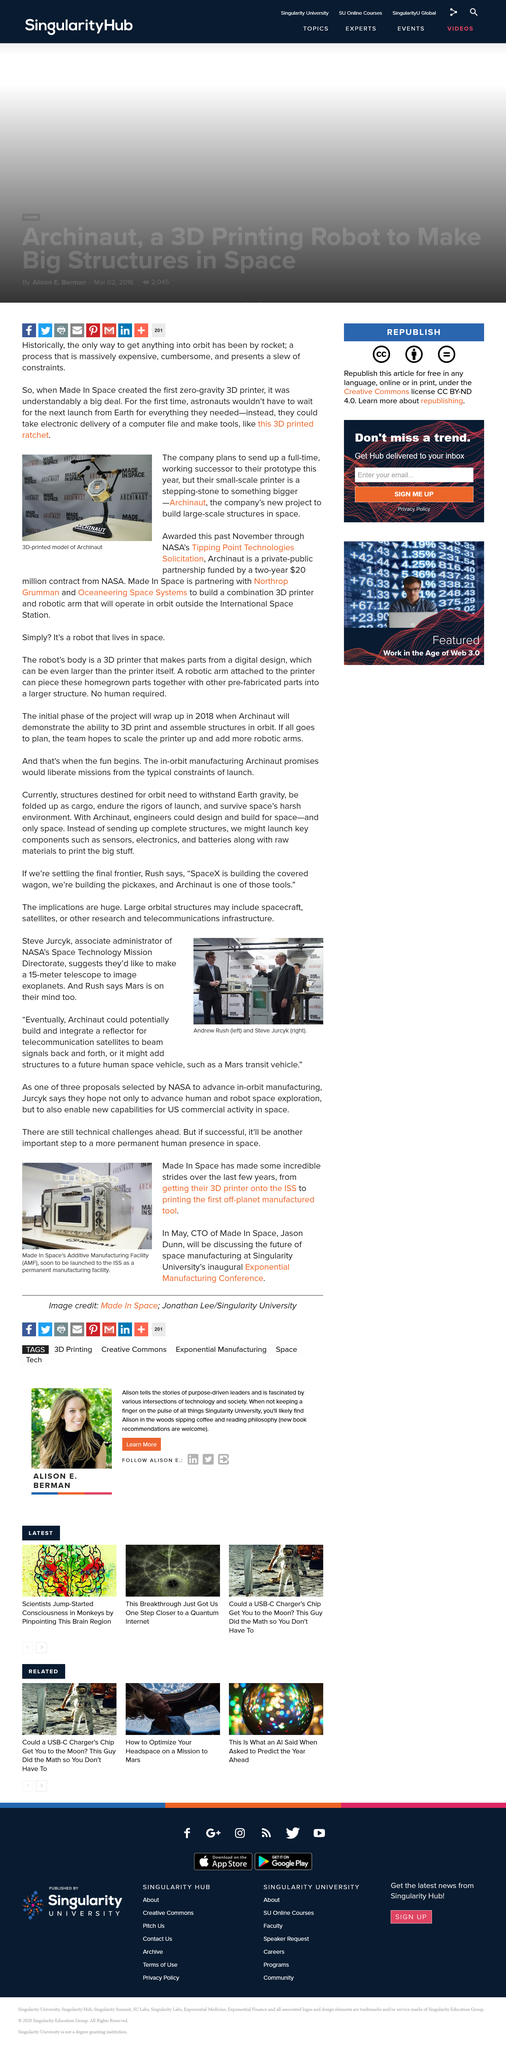Mention a couple of crucial points in this snapshot. Steve Jurcyk is the Associate Administrator of NASA's Space Technology Mission Directorate. Jason Dunn is the Chief Technology Officer of the organization that has achieved remarkable progress over the past few years. Has Made In Space managed to successfully deploy their 3D printer onto the ISS? The acronym "AMF" stands for "Additive Manufacturing Facility," which refers to a facility equipped with the technology and infrastructure necessary to support the creation of three-dimensional objects using additive processes, such as 3D printing. NASA's Space Technology Mission Directorate aims to create a 15-meter telescope for the purpose of imaging exoplanets. 